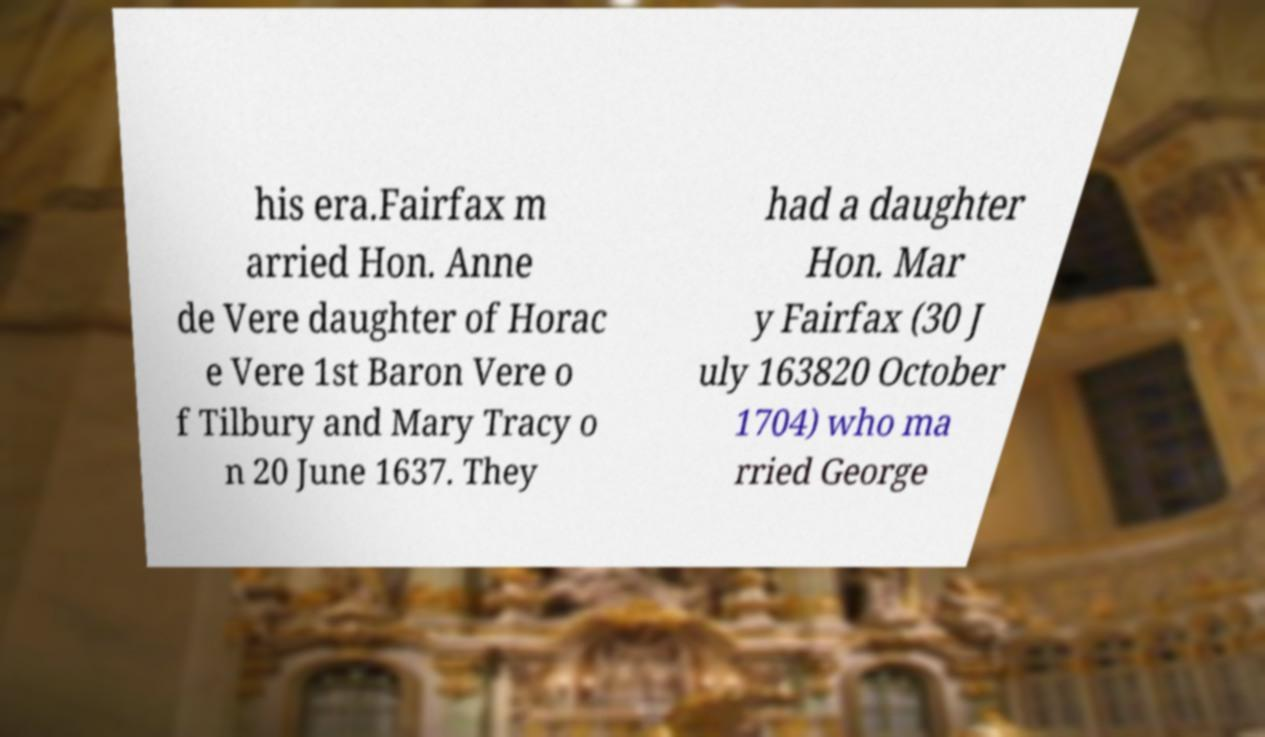Can you read and provide the text displayed in the image?This photo seems to have some interesting text. Can you extract and type it out for me? his era.Fairfax m arried Hon. Anne de Vere daughter of Horac e Vere 1st Baron Vere o f Tilbury and Mary Tracy o n 20 June 1637. They had a daughter Hon. Mar y Fairfax (30 J uly 163820 October 1704) who ma rried George 